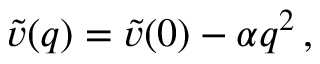<formula> <loc_0><loc_0><loc_500><loc_500>\widetilde { v } ( q ) = \widetilde { v } ( 0 ) - \alpha q ^ { 2 } \, ,</formula> 